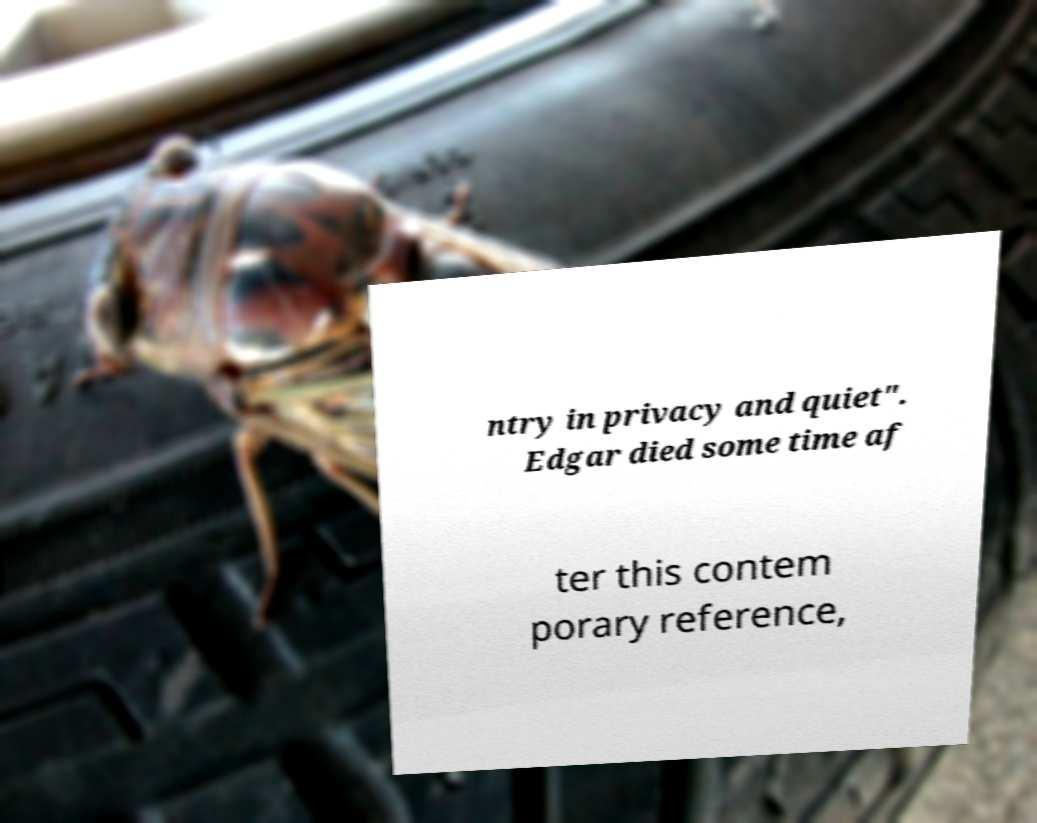Please read and relay the text visible in this image. What does it say? ntry in privacy and quiet". Edgar died some time af ter this contem porary reference, 